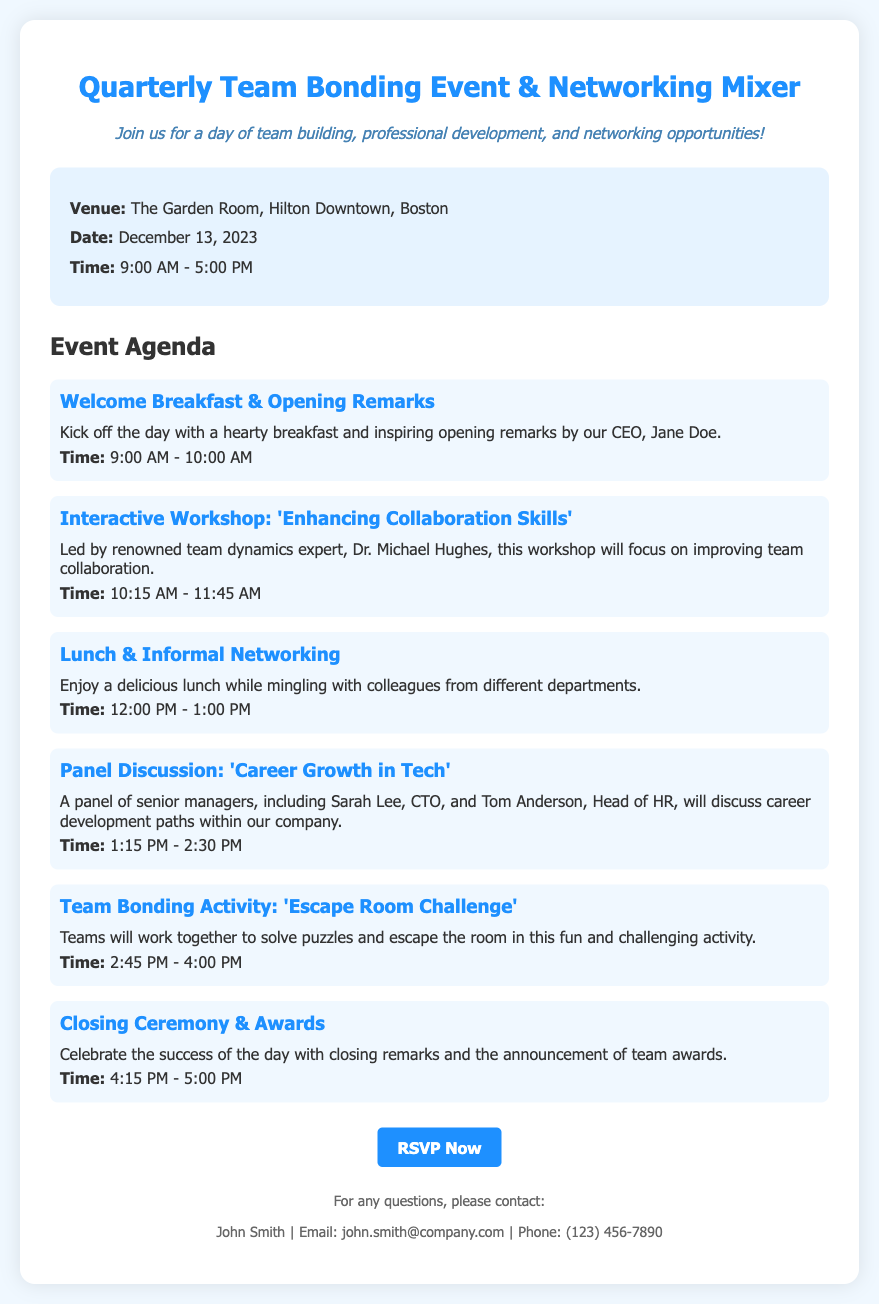What is the venue for the event? The venue is specified in the event details section of the document.
Answer: The Garden Room, Hilton Downtown, Boston What is the date of the event? The date is listed under the event details section.
Answer: December 13, 2023 What time does the event start? The start time of the event is found in the event details section.
Answer: 9:00 AM Who is leading the interactive workshop? The leader of the workshop is mentioned in the agenda section of the document.
Answer: Dr. Michael Hughes What activity follows the lunch? This information is detailed in the agenda section, specifically after the lunch description.
Answer: Panel Discussion: 'Career Growth in Tech' What is the purpose of the closing ceremony? The purpose is stated in the description of the closing ceremony in the agenda section.
Answer: Celebrate the success of the day How many agenda items are there in total? The total count can be derived by counting the agenda items listed in the document.
Answer: Six What can attendees do during the lunch period? The opportunities available during lunch are described in the agenda section.
Answer: Informal Networking Who should be contacted for questions? The contact person is mentioned at the end of the document.
Answer: John Smith 